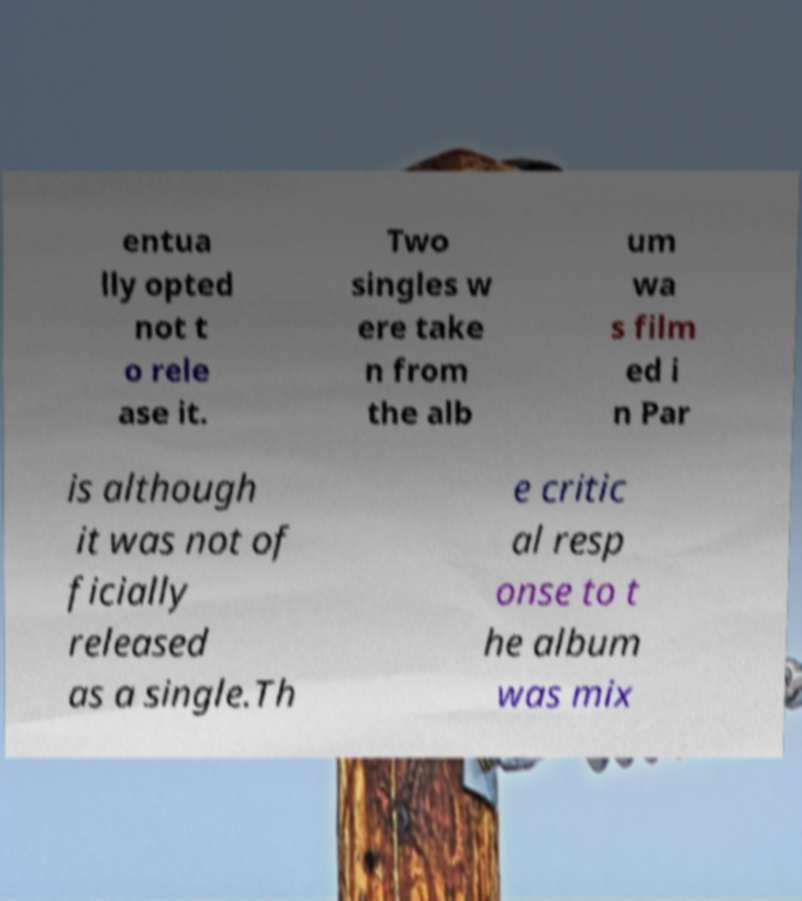Please read and relay the text visible in this image. What does it say? entua lly opted not t o rele ase it. Two singles w ere take n from the alb um wa s film ed i n Par is although it was not of ficially released as a single.Th e critic al resp onse to t he album was mix 